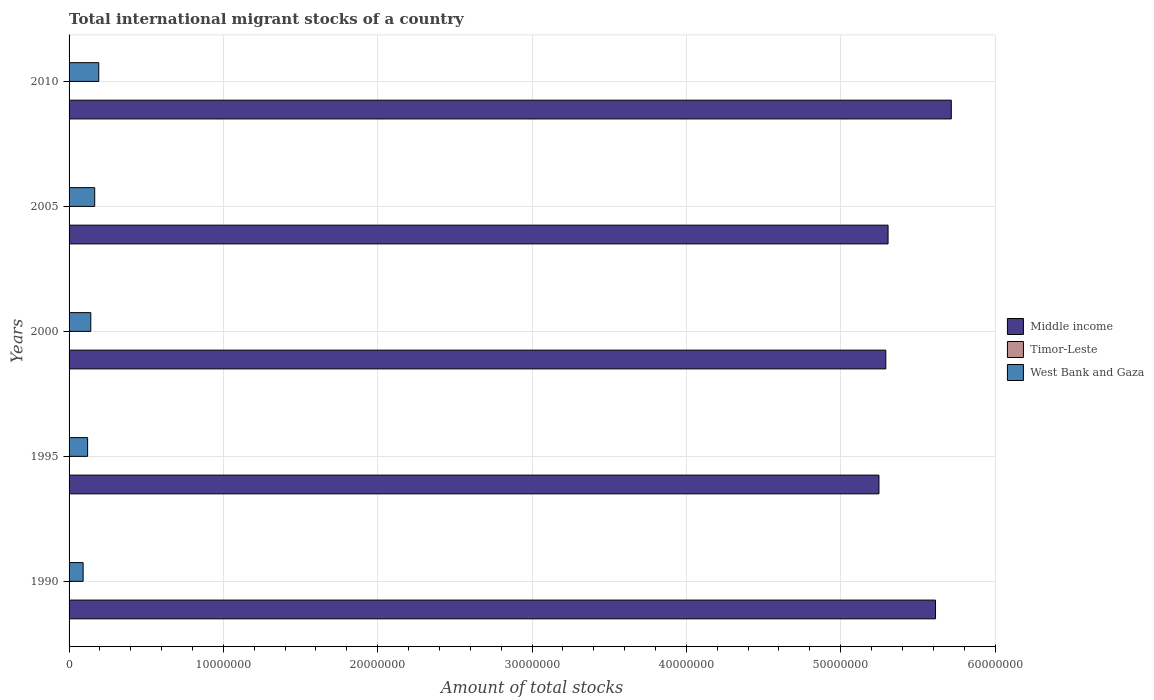How many different coloured bars are there?
Your answer should be very brief. 3. How many groups of bars are there?
Keep it short and to the point. 5. Are the number of bars per tick equal to the number of legend labels?
Provide a succinct answer. Yes. How many bars are there on the 1st tick from the bottom?
Keep it short and to the point. 3. What is the amount of total stocks in in Middle income in 1990?
Ensure brevity in your answer.  5.61e+07. Across all years, what is the maximum amount of total stocks in in West Bank and Gaza?
Give a very brief answer. 1.92e+06. Across all years, what is the minimum amount of total stocks in in West Bank and Gaza?
Ensure brevity in your answer.  9.11e+05. What is the total amount of total stocks in in West Bank and Gaza in the graph?
Give a very brief answer. 7.10e+06. What is the difference between the amount of total stocks in in Middle income in 2000 and that in 2010?
Ensure brevity in your answer.  -4.24e+06. What is the difference between the amount of total stocks in in Timor-Leste in 1990 and the amount of total stocks in in West Bank and Gaza in 2010?
Your answer should be very brief. -1.91e+06. What is the average amount of total stocks in in Middle income per year?
Provide a short and direct response. 5.44e+07. In the year 2000, what is the difference between the amount of total stocks in in West Bank and Gaza and amount of total stocks in in Middle income?
Offer a terse response. -5.15e+07. What is the ratio of the amount of total stocks in in Middle income in 1990 to that in 2010?
Offer a terse response. 0.98. What is the difference between the highest and the second highest amount of total stocks in in Timor-Leste?
Make the answer very short. 1927. What is the difference between the highest and the lowest amount of total stocks in in Timor-Leste?
Give a very brief answer. 4882. In how many years, is the amount of total stocks in in Middle income greater than the average amount of total stocks in in Middle income taken over all years?
Give a very brief answer. 2. Is the sum of the amount of total stocks in in West Bank and Gaza in 2005 and 2010 greater than the maximum amount of total stocks in in Timor-Leste across all years?
Keep it short and to the point. Yes. What does the 1st bar from the top in 1990 represents?
Offer a terse response. West Bank and Gaza. What does the 2nd bar from the bottom in 2005 represents?
Give a very brief answer. Timor-Leste. Is it the case that in every year, the sum of the amount of total stocks in in Timor-Leste and amount of total stocks in in West Bank and Gaza is greater than the amount of total stocks in in Middle income?
Keep it short and to the point. No. How many years are there in the graph?
Provide a succinct answer. 5. Are the values on the major ticks of X-axis written in scientific E-notation?
Ensure brevity in your answer.  No. Does the graph contain grids?
Your response must be concise. Yes. Where does the legend appear in the graph?
Your answer should be compact. Center right. How are the legend labels stacked?
Ensure brevity in your answer.  Vertical. What is the title of the graph?
Keep it short and to the point. Total international migrant stocks of a country. What is the label or title of the X-axis?
Provide a short and direct response. Amount of total stocks. What is the label or title of the Y-axis?
Offer a terse response. Years. What is the Amount of total stocks in Middle income in 1990?
Your answer should be very brief. 5.61e+07. What is the Amount of total stocks of Timor-Leste in 1990?
Ensure brevity in your answer.  8954. What is the Amount of total stocks of West Bank and Gaza in 1990?
Your answer should be very brief. 9.11e+05. What is the Amount of total stocks in Middle income in 1995?
Your answer should be very brief. 5.25e+07. What is the Amount of total stocks of Timor-Leste in 1995?
Offer a terse response. 9652. What is the Amount of total stocks in West Bank and Gaza in 1995?
Ensure brevity in your answer.  1.20e+06. What is the Amount of total stocks of Middle income in 2000?
Your response must be concise. 5.29e+07. What is the Amount of total stocks in Timor-Leste in 2000?
Keep it short and to the point. 9274. What is the Amount of total stocks in West Bank and Gaza in 2000?
Provide a short and direct response. 1.41e+06. What is the Amount of total stocks of Middle income in 2005?
Provide a succinct answer. 5.31e+07. What is the Amount of total stocks in Timor-Leste in 2005?
Your answer should be very brief. 1.19e+04. What is the Amount of total stocks of West Bank and Gaza in 2005?
Make the answer very short. 1.66e+06. What is the Amount of total stocks of Middle income in 2010?
Provide a succinct answer. 5.72e+07. What is the Amount of total stocks of Timor-Leste in 2010?
Make the answer very short. 1.38e+04. What is the Amount of total stocks of West Bank and Gaza in 2010?
Your answer should be compact. 1.92e+06. Across all years, what is the maximum Amount of total stocks of Middle income?
Make the answer very short. 5.72e+07. Across all years, what is the maximum Amount of total stocks in Timor-Leste?
Keep it short and to the point. 1.38e+04. Across all years, what is the maximum Amount of total stocks in West Bank and Gaza?
Give a very brief answer. 1.92e+06. Across all years, what is the minimum Amount of total stocks in Middle income?
Keep it short and to the point. 5.25e+07. Across all years, what is the minimum Amount of total stocks in Timor-Leste?
Make the answer very short. 8954. Across all years, what is the minimum Amount of total stocks of West Bank and Gaza?
Your answer should be compact. 9.11e+05. What is the total Amount of total stocks in Middle income in the graph?
Ensure brevity in your answer.  2.72e+08. What is the total Amount of total stocks in Timor-Leste in the graph?
Your answer should be very brief. 5.36e+04. What is the total Amount of total stocks in West Bank and Gaza in the graph?
Make the answer very short. 7.10e+06. What is the difference between the Amount of total stocks in Middle income in 1990 and that in 1995?
Your answer should be very brief. 3.66e+06. What is the difference between the Amount of total stocks in Timor-Leste in 1990 and that in 1995?
Provide a succinct answer. -698. What is the difference between the Amount of total stocks of West Bank and Gaza in 1990 and that in 1995?
Offer a very short reply. -2.90e+05. What is the difference between the Amount of total stocks in Middle income in 1990 and that in 2000?
Keep it short and to the point. 3.22e+06. What is the difference between the Amount of total stocks of Timor-Leste in 1990 and that in 2000?
Your answer should be compact. -320. What is the difference between the Amount of total stocks of West Bank and Gaza in 1990 and that in 2000?
Offer a very short reply. -4.97e+05. What is the difference between the Amount of total stocks of Middle income in 1990 and that in 2005?
Provide a succinct answer. 3.07e+06. What is the difference between the Amount of total stocks in Timor-Leste in 1990 and that in 2005?
Offer a very short reply. -2955. What is the difference between the Amount of total stocks of West Bank and Gaza in 1990 and that in 2005?
Keep it short and to the point. -7.50e+05. What is the difference between the Amount of total stocks of Middle income in 1990 and that in 2010?
Give a very brief answer. -1.02e+06. What is the difference between the Amount of total stocks in Timor-Leste in 1990 and that in 2010?
Ensure brevity in your answer.  -4882. What is the difference between the Amount of total stocks in West Bank and Gaza in 1990 and that in 2010?
Your response must be concise. -1.01e+06. What is the difference between the Amount of total stocks of Middle income in 1995 and that in 2000?
Give a very brief answer. -4.45e+05. What is the difference between the Amount of total stocks in Timor-Leste in 1995 and that in 2000?
Keep it short and to the point. 378. What is the difference between the Amount of total stocks in West Bank and Gaza in 1995 and that in 2000?
Your answer should be very brief. -2.07e+05. What is the difference between the Amount of total stocks of Middle income in 1995 and that in 2005?
Give a very brief answer. -5.90e+05. What is the difference between the Amount of total stocks in Timor-Leste in 1995 and that in 2005?
Your answer should be very brief. -2257. What is the difference between the Amount of total stocks of West Bank and Gaza in 1995 and that in 2005?
Your answer should be very brief. -4.60e+05. What is the difference between the Amount of total stocks of Middle income in 1995 and that in 2010?
Provide a succinct answer. -4.69e+06. What is the difference between the Amount of total stocks in Timor-Leste in 1995 and that in 2010?
Provide a short and direct response. -4184. What is the difference between the Amount of total stocks in West Bank and Gaza in 1995 and that in 2010?
Provide a short and direct response. -7.23e+05. What is the difference between the Amount of total stocks of Middle income in 2000 and that in 2005?
Give a very brief answer. -1.45e+05. What is the difference between the Amount of total stocks of Timor-Leste in 2000 and that in 2005?
Offer a terse response. -2635. What is the difference between the Amount of total stocks of West Bank and Gaza in 2000 and that in 2005?
Keep it short and to the point. -2.53e+05. What is the difference between the Amount of total stocks in Middle income in 2000 and that in 2010?
Provide a succinct answer. -4.24e+06. What is the difference between the Amount of total stocks of Timor-Leste in 2000 and that in 2010?
Keep it short and to the point. -4562. What is the difference between the Amount of total stocks in West Bank and Gaza in 2000 and that in 2010?
Offer a terse response. -5.16e+05. What is the difference between the Amount of total stocks of Middle income in 2005 and that in 2010?
Keep it short and to the point. -4.10e+06. What is the difference between the Amount of total stocks in Timor-Leste in 2005 and that in 2010?
Provide a short and direct response. -1927. What is the difference between the Amount of total stocks of West Bank and Gaza in 2005 and that in 2010?
Your response must be concise. -2.63e+05. What is the difference between the Amount of total stocks of Middle income in 1990 and the Amount of total stocks of Timor-Leste in 1995?
Ensure brevity in your answer.  5.61e+07. What is the difference between the Amount of total stocks of Middle income in 1990 and the Amount of total stocks of West Bank and Gaza in 1995?
Keep it short and to the point. 5.49e+07. What is the difference between the Amount of total stocks of Timor-Leste in 1990 and the Amount of total stocks of West Bank and Gaza in 1995?
Provide a succinct answer. -1.19e+06. What is the difference between the Amount of total stocks in Middle income in 1990 and the Amount of total stocks in Timor-Leste in 2000?
Offer a very short reply. 5.61e+07. What is the difference between the Amount of total stocks in Middle income in 1990 and the Amount of total stocks in West Bank and Gaza in 2000?
Ensure brevity in your answer.  5.47e+07. What is the difference between the Amount of total stocks in Timor-Leste in 1990 and the Amount of total stocks in West Bank and Gaza in 2000?
Offer a very short reply. -1.40e+06. What is the difference between the Amount of total stocks in Middle income in 1990 and the Amount of total stocks in Timor-Leste in 2005?
Your response must be concise. 5.61e+07. What is the difference between the Amount of total stocks in Middle income in 1990 and the Amount of total stocks in West Bank and Gaza in 2005?
Keep it short and to the point. 5.45e+07. What is the difference between the Amount of total stocks of Timor-Leste in 1990 and the Amount of total stocks of West Bank and Gaza in 2005?
Ensure brevity in your answer.  -1.65e+06. What is the difference between the Amount of total stocks of Middle income in 1990 and the Amount of total stocks of Timor-Leste in 2010?
Make the answer very short. 5.61e+07. What is the difference between the Amount of total stocks in Middle income in 1990 and the Amount of total stocks in West Bank and Gaza in 2010?
Offer a terse response. 5.42e+07. What is the difference between the Amount of total stocks of Timor-Leste in 1990 and the Amount of total stocks of West Bank and Gaza in 2010?
Offer a very short reply. -1.91e+06. What is the difference between the Amount of total stocks in Middle income in 1995 and the Amount of total stocks in Timor-Leste in 2000?
Ensure brevity in your answer.  5.25e+07. What is the difference between the Amount of total stocks of Middle income in 1995 and the Amount of total stocks of West Bank and Gaza in 2000?
Your answer should be very brief. 5.11e+07. What is the difference between the Amount of total stocks of Timor-Leste in 1995 and the Amount of total stocks of West Bank and Gaza in 2000?
Provide a short and direct response. -1.40e+06. What is the difference between the Amount of total stocks of Middle income in 1995 and the Amount of total stocks of Timor-Leste in 2005?
Offer a terse response. 5.25e+07. What is the difference between the Amount of total stocks of Middle income in 1995 and the Amount of total stocks of West Bank and Gaza in 2005?
Make the answer very short. 5.08e+07. What is the difference between the Amount of total stocks in Timor-Leste in 1995 and the Amount of total stocks in West Bank and Gaza in 2005?
Your answer should be very brief. -1.65e+06. What is the difference between the Amount of total stocks in Middle income in 1995 and the Amount of total stocks in Timor-Leste in 2010?
Keep it short and to the point. 5.25e+07. What is the difference between the Amount of total stocks of Middle income in 1995 and the Amount of total stocks of West Bank and Gaza in 2010?
Give a very brief answer. 5.06e+07. What is the difference between the Amount of total stocks of Timor-Leste in 1995 and the Amount of total stocks of West Bank and Gaza in 2010?
Your answer should be very brief. -1.91e+06. What is the difference between the Amount of total stocks of Middle income in 2000 and the Amount of total stocks of Timor-Leste in 2005?
Offer a very short reply. 5.29e+07. What is the difference between the Amount of total stocks of Middle income in 2000 and the Amount of total stocks of West Bank and Gaza in 2005?
Offer a terse response. 5.13e+07. What is the difference between the Amount of total stocks in Timor-Leste in 2000 and the Amount of total stocks in West Bank and Gaza in 2005?
Give a very brief answer. -1.65e+06. What is the difference between the Amount of total stocks in Middle income in 2000 and the Amount of total stocks in Timor-Leste in 2010?
Keep it short and to the point. 5.29e+07. What is the difference between the Amount of total stocks in Middle income in 2000 and the Amount of total stocks in West Bank and Gaza in 2010?
Your answer should be very brief. 5.10e+07. What is the difference between the Amount of total stocks of Timor-Leste in 2000 and the Amount of total stocks of West Bank and Gaza in 2010?
Make the answer very short. -1.91e+06. What is the difference between the Amount of total stocks of Middle income in 2005 and the Amount of total stocks of Timor-Leste in 2010?
Ensure brevity in your answer.  5.31e+07. What is the difference between the Amount of total stocks of Middle income in 2005 and the Amount of total stocks of West Bank and Gaza in 2010?
Ensure brevity in your answer.  5.11e+07. What is the difference between the Amount of total stocks in Timor-Leste in 2005 and the Amount of total stocks in West Bank and Gaza in 2010?
Your answer should be compact. -1.91e+06. What is the average Amount of total stocks in Middle income per year?
Make the answer very short. 5.44e+07. What is the average Amount of total stocks in Timor-Leste per year?
Keep it short and to the point. 1.07e+04. What is the average Amount of total stocks in West Bank and Gaza per year?
Give a very brief answer. 1.42e+06. In the year 1990, what is the difference between the Amount of total stocks of Middle income and Amount of total stocks of Timor-Leste?
Offer a very short reply. 5.61e+07. In the year 1990, what is the difference between the Amount of total stocks in Middle income and Amount of total stocks in West Bank and Gaza?
Offer a terse response. 5.52e+07. In the year 1990, what is the difference between the Amount of total stocks in Timor-Leste and Amount of total stocks in West Bank and Gaza?
Provide a succinct answer. -9.02e+05. In the year 1995, what is the difference between the Amount of total stocks in Middle income and Amount of total stocks in Timor-Leste?
Your answer should be compact. 5.25e+07. In the year 1995, what is the difference between the Amount of total stocks in Middle income and Amount of total stocks in West Bank and Gaza?
Make the answer very short. 5.13e+07. In the year 1995, what is the difference between the Amount of total stocks of Timor-Leste and Amount of total stocks of West Bank and Gaza?
Give a very brief answer. -1.19e+06. In the year 2000, what is the difference between the Amount of total stocks of Middle income and Amount of total stocks of Timor-Leste?
Your answer should be very brief. 5.29e+07. In the year 2000, what is the difference between the Amount of total stocks of Middle income and Amount of total stocks of West Bank and Gaza?
Offer a very short reply. 5.15e+07. In the year 2000, what is the difference between the Amount of total stocks in Timor-Leste and Amount of total stocks in West Bank and Gaza?
Provide a short and direct response. -1.40e+06. In the year 2005, what is the difference between the Amount of total stocks of Middle income and Amount of total stocks of Timor-Leste?
Offer a terse response. 5.31e+07. In the year 2005, what is the difference between the Amount of total stocks in Middle income and Amount of total stocks in West Bank and Gaza?
Your response must be concise. 5.14e+07. In the year 2005, what is the difference between the Amount of total stocks of Timor-Leste and Amount of total stocks of West Bank and Gaza?
Keep it short and to the point. -1.65e+06. In the year 2010, what is the difference between the Amount of total stocks of Middle income and Amount of total stocks of Timor-Leste?
Your response must be concise. 5.72e+07. In the year 2010, what is the difference between the Amount of total stocks of Middle income and Amount of total stocks of West Bank and Gaza?
Provide a succinct answer. 5.52e+07. In the year 2010, what is the difference between the Amount of total stocks in Timor-Leste and Amount of total stocks in West Bank and Gaza?
Make the answer very short. -1.91e+06. What is the ratio of the Amount of total stocks of Middle income in 1990 to that in 1995?
Give a very brief answer. 1.07. What is the ratio of the Amount of total stocks of Timor-Leste in 1990 to that in 1995?
Make the answer very short. 0.93. What is the ratio of the Amount of total stocks of West Bank and Gaza in 1990 to that in 1995?
Make the answer very short. 0.76. What is the ratio of the Amount of total stocks of Middle income in 1990 to that in 2000?
Your answer should be very brief. 1.06. What is the ratio of the Amount of total stocks in Timor-Leste in 1990 to that in 2000?
Make the answer very short. 0.97. What is the ratio of the Amount of total stocks of West Bank and Gaza in 1990 to that in 2000?
Ensure brevity in your answer.  0.65. What is the ratio of the Amount of total stocks of Middle income in 1990 to that in 2005?
Give a very brief answer. 1.06. What is the ratio of the Amount of total stocks in Timor-Leste in 1990 to that in 2005?
Give a very brief answer. 0.75. What is the ratio of the Amount of total stocks of West Bank and Gaza in 1990 to that in 2005?
Give a very brief answer. 0.55. What is the ratio of the Amount of total stocks in Middle income in 1990 to that in 2010?
Your answer should be very brief. 0.98. What is the ratio of the Amount of total stocks in Timor-Leste in 1990 to that in 2010?
Your answer should be compact. 0.65. What is the ratio of the Amount of total stocks in West Bank and Gaza in 1990 to that in 2010?
Your response must be concise. 0.47. What is the ratio of the Amount of total stocks of Middle income in 1995 to that in 2000?
Give a very brief answer. 0.99. What is the ratio of the Amount of total stocks in Timor-Leste in 1995 to that in 2000?
Give a very brief answer. 1.04. What is the ratio of the Amount of total stocks in West Bank and Gaza in 1995 to that in 2000?
Offer a terse response. 0.85. What is the ratio of the Amount of total stocks of Middle income in 1995 to that in 2005?
Provide a succinct answer. 0.99. What is the ratio of the Amount of total stocks in Timor-Leste in 1995 to that in 2005?
Your answer should be very brief. 0.81. What is the ratio of the Amount of total stocks of West Bank and Gaza in 1995 to that in 2005?
Provide a short and direct response. 0.72. What is the ratio of the Amount of total stocks in Middle income in 1995 to that in 2010?
Provide a succinct answer. 0.92. What is the ratio of the Amount of total stocks of Timor-Leste in 1995 to that in 2010?
Offer a very short reply. 0.7. What is the ratio of the Amount of total stocks in West Bank and Gaza in 1995 to that in 2010?
Your answer should be compact. 0.62. What is the ratio of the Amount of total stocks in Timor-Leste in 2000 to that in 2005?
Your response must be concise. 0.78. What is the ratio of the Amount of total stocks of West Bank and Gaza in 2000 to that in 2005?
Your response must be concise. 0.85. What is the ratio of the Amount of total stocks of Middle income in 2000 to that in 2010?
Your answer should be very brief. 0.93. What is the ratio of the Amount of total stocks of Timor-Leste in 2000 to that in 2010?
Offer a very short reply. 0.67. What is the ratio of the Amount of total stocks in West Bank and Gaza in 2000 to that in 2010?
Ensure brevity in your answer.  0.73. What is the ratio of the Amount of total stocks in Middle income in 2005 to that in 2010?
Give a very brief answer. 0.93. What is the ratio of the Amount of total stocks in Timor-Leste in 2005 to that in 2010?
Your response must be concise. 0.86. What is the ratio of the Amount of total stocks in West Bank and Gaza in 2005 to that in 2010?
Offer a terse response. 0.86. What is the difference between the highest and the second highest Amount of total stocks in Middle income?
Offer a terse response. 1.02e+06. What is the difference between the highest and the second highest Amount of total stocks in Timor-Leste?
Provide a succinct answer. 1927. What is the difference between the highest and the second highest Amount of total stocks of West Bank and Gaza?
Your answer should be very brief. 2.63e+05. What is the difference between the highest and the lowest Amount of total stocks in Middle income?
Offer a terse response. 4.69e+06. What is the difference between the highest and the lowest Amount of total stocks in Timor-Leste?
Offer a terse response. 4882. What is the difference between the highest and the lowest Amount of total stocks in West Bank and Gaza?
Offer a terse response. 1.01e+06. 